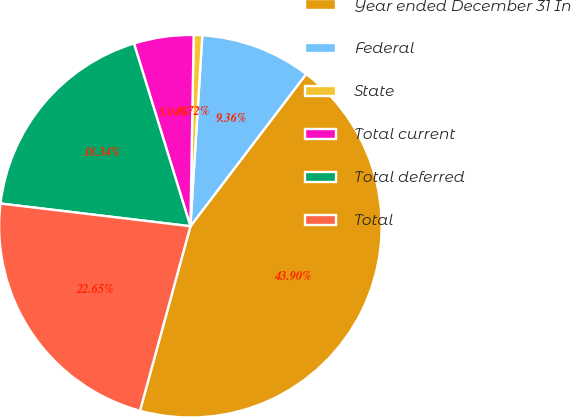Convert chart. <chart><loc_0><loc_0><loc_500><loc_500><pie_chart><fcel>Year ended December 31 In<fcel>Federal<fcel>State<fcel>Total current<fcel>Total deferred<fcel>Total<nl><fcel>43.9%<fcel>9.36%<fcel>0.72%<fcel>5.04%<fcel>18.34%<fcel>22.65%<nl></chart> 